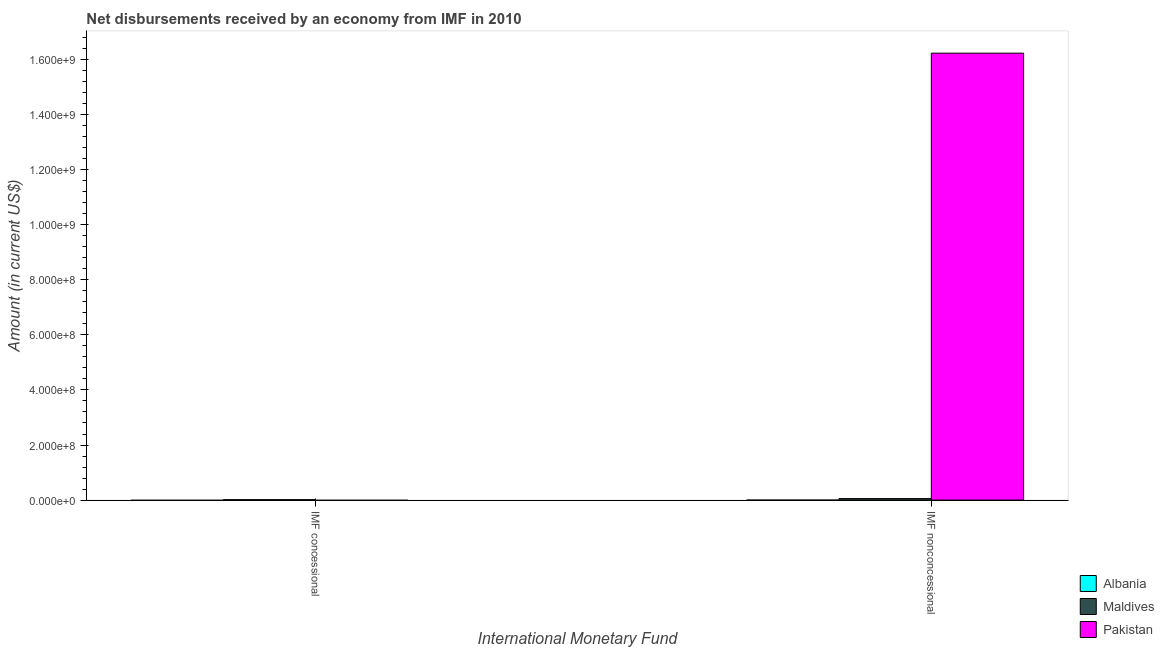Are the number of bars per tick equal to the number of legend labels?
Your answer should be compact. No. How many bars are there on the 1st tick from the left?
Make the answer very short. 1. How many bars are there on the 1st tick from the right?
Make the answer very short. 2. What is the label of the 1st group of bars from the left?
Keep it short and to the point. IMF concessional. What is the net non concessional disbursements from imf in Maldives?
Give a very brief answer. 5.47e+06. Across all countries, what is the maximum net concessional disbursements from imf?
Make the answer very short. 1.56e+06. In which country was the net concessional disbursements from imf maximum?
Provide a short and direct response. Maldives. What is the total net non concessional disbursements from imf in the graph?
Offer a terse response. 1.63e+09. What is the difference between the net non concessional disbursements from imf in Pakistan and that in Maldives?
Make the answer very short. 1.62e+09. What is the difference between the net concessional disbursements from imf in Albania and the net non concessional disbursements from imf in Pakistan?
Your response must be concise. -1.62e+09. What is the average net concessional disbursements from imf per country?
Your answer should be compact. 5.21e+05. What is the difference between the net concessional disbursements from imf and net non concessional disbursements from imf in Maldives?
Offer a very short reply. -3.91e+06. In how many countries, is the net non concessional disbursements from imf greater than 1600000000 US$?
Your answer should be very brief. 1. Are all the bars in the graph horizontal?
Your answer should be compact. No. How many countries are there in the graph?
Your answer should be compact. 3. What is the difference between two consecutive major ticks on the Y-axis?
Offer a terse response. 2.00e+08. Where does the legend appear in the graph?
Make the answer very short. Bottom right. How are the legend labels stacked?
Your response must be concise. Vertical. What is the title of the graph?
Your answer should be very brief. Net disbursements received by an economy from IMF in 2010. Does "Armenia" appear as one of the legend labels in the graph?
Keep it short and to the point. No. What is the label or title of the X-axis?
Provide a succinct answer. International Monetary Fund. What is the label or title of the Y-axis?
Provide a succinct answer. Amount (in current US$). What is the Amount (in current US$) in Maldives in IMF concessional?
Keep it short and to the point. 1.56e+06. What is the Amount (in current US$) in Pakistan in IMF concessional?
Your response must be concise. 0. What is the Amount (in current US$) of Maldives in IMF nonconcessional?
Your response must be concise. 5.47e+06. What is the Amount (in current US$) in Pakistan in IMF nonconcessional?
Your response must be concise. 1.62e+09. Across all International Monetary Fund, what is the maximum Amount (in current US$) of Maldives?
Your response must be concise. 5.47e+06. Across all International Monetary Fund, what is the maximum Amount (in current US$) in Pakistan?
Provide a succinct answer. 1.62e+09. Across all International Monetary Fund, what is the minimum Amount (in current US$) of Maldives?
Offer a terse response. 1.56e+06. Across all International Monetary Fund, what is the minimum Amount (in current US$) in Pakistan?
Give a very brief answer. 0. What is the total Amount (in current US$) of Albania in the graph?
Your answer should be very brief. 0. What is the total Amount (in current US$) of Maldives in the graph?
Your response must be concise. 7.04e+06. What is the total Amount (in current US$) in Pakistan in the graph?
Give a very brief answer. 1.62e+09. What is the difference between the Amount (in current US$) of Maldives in IMF concessional and that in IMF nonconcessional?
Ensure brevity in your answer.  -3.91e+06. What is the difference between the Amount (in current US$) in Maldives in IMF concessional and the Amount (in current US$) in Pakistan in IMF nonconcessional?
Offer a terse response. -1.62e+09. What is the average Amount (in current US$) in Maldives per International Monetary Fund?
Your answer should be compact. 3.52e+06. What is the average Amount (in current US$) in Pakistan per International Monetary Fund?
Keep it short and to the point. 8.12e+08. What is the difference between the Amount (in current US$) in Maldives and Amount (in current US$) in Pakistan in IMF nonconcessional?
Your answer should be very brief. -1.62e+09. What is the ratio of the Amount (in current US$) of Maldives in IMF concessional to that in IMF nonconcessional?
Your response must be concise. 0.29. What is the difference between the highest and the second highest Amount (in current US$) of Maldives?
Your response must be concise. 3.91e+06. What is the difference between the highest and the lowest Amount (in current US$) in Maldives?
Make the answer very short. 3.91e+06. What is the difference between the highest and the lowest Amount (in current US$) of Pakistan?
Your answer should be compact. 1.62e+09. 